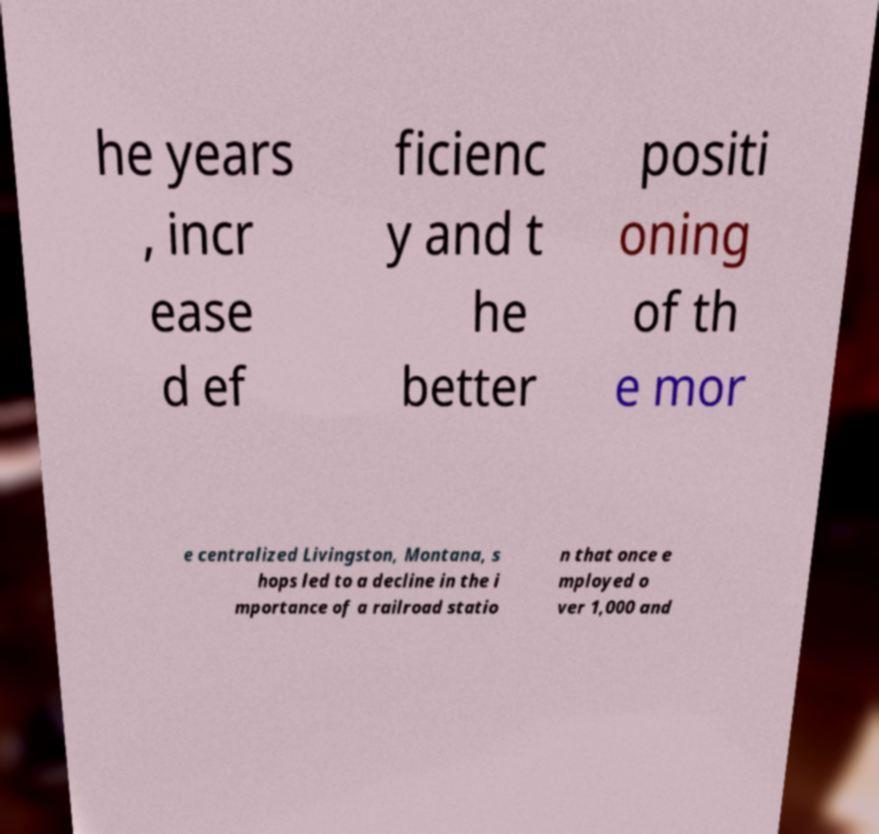What messages or text are displayed in this image? I need them in a readable, typed format. he years , incr ease d ef ficienc y and t he better positi oning of th e mor e centralized Livingston, Montana, s hops led to a decline in the i mportance of a railroad statio n that once e mployed o ver 1,000 and 